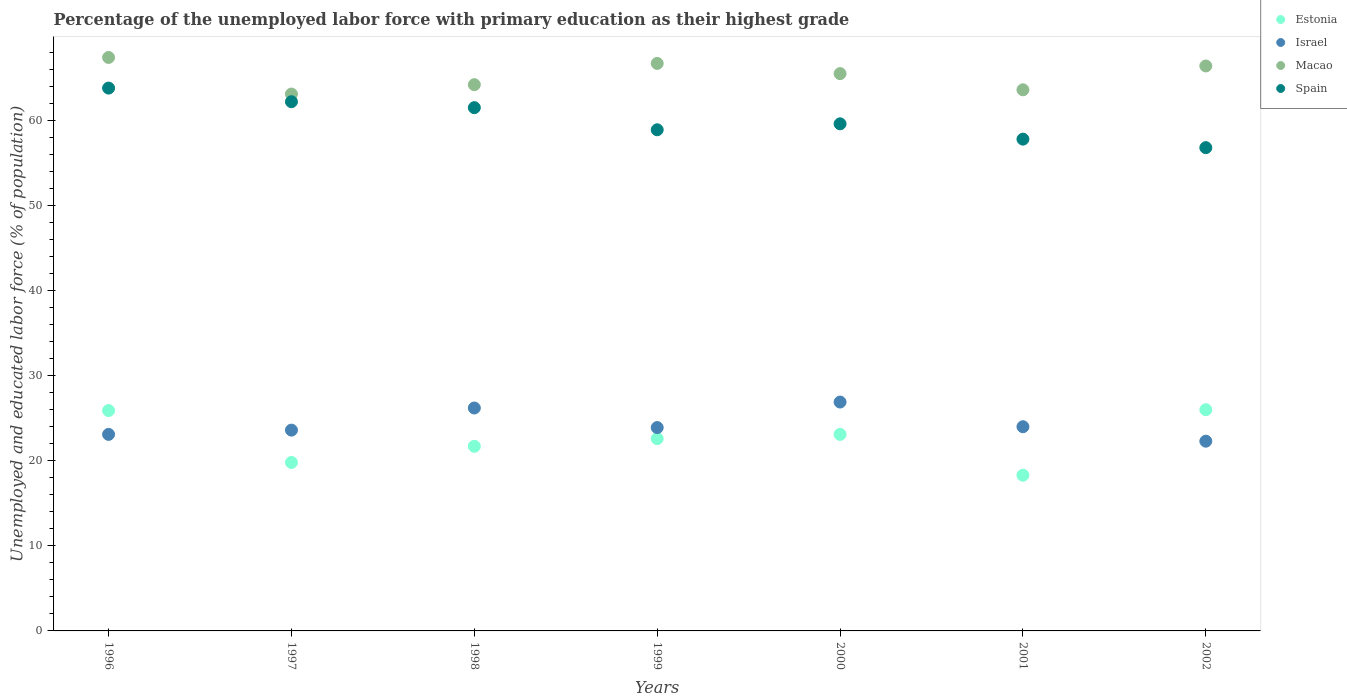Is the number of dotlines equal to the number of legend labels?
Ensure brevity in your answer.  Yes. What is the percentage of the unemployed labor force with primary education in Israel in 2001?
Offer a very short reply. 24. Across all years, what is the maximum percentage of the unemployed labor force with primary education in Spain?
Ensure brevity in your answer.  63.8. Across all years, what is the minimum percentage of the unemployed labor force with primary education in Macao?
Provide a succinct answer. 63.1. In which year was the percentage of the unemployed labor force with primary education in Spain minimum?
Ensure brevity in your answer.  2002. What is the total percentage of the unemployed labor force with primary education in Macao in the graph?
Provide a short and direct response. 456.9. What is the difference between the percentage of the unemployed labor force with primary education in Macao in 1996 and that in 1997?
Offer a very short reply. 4.3. What is the difference between the percentage of the unemployed labor force with primary education in Estonia in 2001 and the percentage of the unemployed labor force with primary education in Macao in 1996?
Your answer should be compact. -49.1. What is the average percentage of the unemployed labor force with primary education in Estonia per year?
Your answer should be compact. 22.49. In the year 1998, what is the difference between the percentage of the unemployed labor force with primary education in Israel and percentage of the unemployed labor force with primary education in Spain?
Offer a very short reply. -35.3. What is the ratio of the percentage of the unemployed labor force with primary education in Macao in 1999 to that in 2000?
Ensure brevity in your answer.  1.02. Is the percentage of the unemployed labor force with primary education in Israel in 1997 less than that in 1998?
Your answer should be compact. Yes. Is the difference between the percentage of the unemployed labor force with primary education in Israel in 1999 and 2002 greater than the difference between the percentage of the unemployed labor force with primary education in Spain in 1999 and 2002?
Keep it short and to the point. No. What is the difference between the highest and the second highest percentage of the unemployed labor force with primary education in Estonia?
Ensure brevity in your answer.  0.1. What is the difference between the highest and the lowest percentage of the unemployed labor force with primary education in Macao?
Ensure brevity in your answer.  4.3. In how many years, is the percentage of the unemployed labor force with primary education in Macao greater than the average percentage of the unemployed labor force with primary education in Macao taken over all years?
Make the answer very short. 4. Is it the case that in every year, the sum of the percentage of the unemployed labor force with primary education in Estonia and percentage of the unemployed labor force with primary education in Macao  is greater than the sum of percentage of the unemployed labor force with primary education in Spain and percentage of the unemployed labor force with primary education in Israel?
Provide a succinct answer. No. Is the percentage of the unemployed labor force with primary education in Spain strictly greater than the percentage of the unemployed labor force with primary education in Israel over the years?
Ensure brevity in your answer.  Yes. What is the difference between two consecutive major ticks on the Y-axis?
Give a very brief answer. 10. Are the values on the major ticks of Y-axis written in scientific E-notation?
Offer a very short reply. No. Where does the legend appear in the graph?
Give a very brief answer. Top right. How are the legend labels stacked?
Your answer should be very brief. Vertical. What is the title of the graph?
Provide a succinct answer. Percentage of the unemployed labor force with primary education as their highest grade. What is the label or title of the X-axis?
Your response must be concise. Years. What is the label or title of the Y-axis?
Give a very brief answer. Unemployed and educated labor force (% of population). What is the Unemployed and educated labor force (% of population) of Estonia in 1996?
Your answer should be very brief. 25.9. What is the Unemployed and educated labor force (% of population) in Israel in 1996?
Give a very brief answer. 23.1. What is the Unemployed and educated labor force (% of population) of Macao in 1996?
Give a very brief answer. 67.4. What is the Unemployed and educated labor force (% of population) in Spain in 1996?
Give a very brief answer. 63.8. What is the Unemployed and educated labor force (% of population) in Estonia in 1997?
Give a very brief answer. 19.8. What is the Unemployed and educated labor force (% of population) of Israel in 1997?
Your answer should be compact. 23.6. What is the Unemployed and educated labor force (% of population) in Macao in 1997?
Ensure brevity in your answer.  63.1. What is the Unemployed and educated labor force (% of population) in Spain in 1997?
Your answer should be very brief. 62.2. What is the Unemployed and educated labor force (% of population) in Estonia in 1998?
Ensure brevity in your answer.  21.7. What is the Unemployed and educated labor force (% of population) of Israel in 1998?
Offer a terse response. 26.2. What is the Unemployed and educated labor force (% of population) in Macao in 1998?
Give a very brief answer. 64.2. What is the Unemployed and educated labor force (% of population) in Spain in 1998?
Offer a very short reply. 61.5. What is the Unemployed and educated labor force (% of population) in Estonia in 1999?
Offer a terse response. 22.6. What is the Unemployed and educated labor force (% of population) in Israel in 1999?
Your response must be concise. 23.9. What is the Unemployed and educated labor force (% of population) of Macao in 1999?
Give a very brief answer. 66.7. What is the Unemployed and educated labor force (% of population) in Spain in 1999?
Offer a very short reply. 58.9. What is the Unemployed and educated labor force (% of population) of Estonia in 2000?
Offer a terse response. 23.1. What is the Unemployed and educated labor force (% of population) of Israel in 2000?
Your response must be concise. 26.9. What is the Unemployed and educated labor force (% of population) in Macao in 2000?
Offer a very short reply. 65.5. What is the Unemployed and educated labor force (% of population) in Spain in 2000?
Offer a terse response. 59.6. What is the Unemployed and educated labor force (% of population) in Estonia in 2001?
Give a very brief answer. 18.3. What is the Unemployed and educated labor force (% of population) of Macao in 2001?
Ensure brevity in your answer.  63.6. What is the Unemployed and educated labor force (% of population) of Spain in 2001?
Offer a very short reply. 57.8. What is the Unemployed and educated labor force (% of population) in Israel in 2002?
Ensure brevity in your answer.  22.3. What is the Unemployed and educated labor force (% of population) of Macao in 2002?
Provide a succinct answer. 66.4. What is the Unemployed and educated labor force (% of population) in Spain in 2002?
Offer a very short reply. 56.8. Across all years, what is the maximum Unemployed and educated labor force (% of population) in Israel?
Your response must be concise. 26.9. Across all years, what is the maximum Unemployed and educated labor force (% of population) in Macao?
Offer a terse response. 67.4. Across all years, what is the maximum Unemployed and educated labor force (% of population) of Spain?
Provide a short and direct response. 63.8. Across all years, what is the minimum Unemployed and educated labor force (% of population) in Estonia?
Your answer should be compact. 18.3. Across all years, what is the minimum Unemployed and educated labor force (% of population) of Israel?
Your response must be concise. 22.3. Across all years, what is the minimum Unemployed and educated labor force (% of population) in Macao?
Make the answer very short. 63.1. Across all years, what is the minimum Unemployed and educated labor force (% of population) of Spain?
Your response must be concise. 56.8. What is the total Unemployed and educated labor force (% of population) in Estonia in the graph?
Ensure brevity in your answer.  157.4. What is the total Unemployed and educated labor force (% of population) in Israel in the graph?
Keep it short and to the point. 170. What is the total Unemployed and educated labor force (% of population) of Macao in the graph?
Your answer should be very brief. 456.9. What is the total Unemployed and educated labor force (% of population) of Spain in the graph?
Your answer should be very brief. 420.6. What is the difference between the Unemployed and educated labor force (% of population) of Estonia in 1996 and that in 1997?
Ensure brevity in your answer.  6.1. What is the difference between the Unemployed and educated labor force (% of population) of Macao in 1996 and that in 1997?
Keep it short and to the point. 4.3. What is the difference between the Unemployed and educated labor force (% of population) in Spain in 1996 and that in 1997?
Provide a short and direct response. 1.6. What is the difference between the Unemployed and educated labor force (% of population) in Israel in 1996 and that in 1998?
Offer a very short reply. -3.1. What is the difference between the Unemployed and educated labor force (% of population) in Macao in 1996 and that in 1998?
Your answer should be very brief. 3.2. What is the difference between the Unemployed and educated labor force (% of population) of Estonia in 1996 and that in 1999?
Your answer should be compact. 3.3. What is the difference between the Unemployed and educated labor force (% of population) in Israel in 1996 and that in 1999?
Make the answer very short. -0.8. What is the difference between the Unemployed and educated labor force (% of population) of Macao in 1996 and that in 1999?
Give a very brief answer. 0.7. What is the difference between the Unemployed and educated labor force (% of population) in Israel in 1996 and that in 2000?
Ensure brevity in your answer.  -3.8. What is the difference between the Unemployed and educated labor force (% of population) in Estonia in 1996 and that in 2001?
Give a very brief answer. 7.6. What is the difference between the Unemployed and educated labor force (% of population) in Macao in 1996 and that in 2001?
Offer a very short reply. 3.8. What is the difference between the Unemployed and educated labor force (% of population) of Israel in 1996 and that in 2002?
Keep it short and to the point. 0.8. What is the difference between the Unemployed and educated labor force (% of population) of Macao in 1996 and that in 2002?
Offer a terse response. 1. What is the difference between the Unemployed and educated labor force (% of population) of Estonia in 1997 and that in 1998?
Provide a succinct answer. -1.9. What is the difference between the Unemployed and educated labor force (% of population) of Israel in 1997 and that in 1998?
Offer a terse response. -2.6. What is the difference between the Unemployed and educated labor force (% of population) of Spain in 1997 and that in 1998?
Provide a short and direct response. 0.7. What is the difference between the Unemployed and educated labor force (% of population) of Estonia in 1997 and that in 1999?
Your response must be concise. -2.8. What is the difference between the Unemployed and educated labor force (% of population) in Israel in 1997 and that in 1999?
Give a very brief answer. -0.3. What is the difference between the Unemployed and educated labor force (% of population) of Estonia in 1997 and that in 2000?
Provide a succinct answer. -3.3. What is the difference between the Unemployed and educated labor force (% of population) of Israel in 1997 and that in 2000?
Ensure brevity in your answer.  -3.3. What is the difference between the Unemployed and educated labor force (% of population) in Macao in 1997 and that in 2000?
Your answer should be compact. -2.4. What is the difference between the Unemployed and educated labor force (% of population) of Spain in 1997 and that in 2000?
Make the answer very short. 2.6. What is the difference between the Unemployed and educated labor force (% of population) of Macao in 1997 and that in 2001?
Keep it short and to the point. -0.5. What is the difference between the Unemployed and educated labor force (% of population) in Estonia in 1997 and that in 2002?
Ensure brevity in your answer.  -6.2. What is the difference between the Unemployed and educated labor force (% of population) of Israel in 1997 and that in 2002?
Provide a succinct answer. 1.3. What is the difference between the Unemployed and educated labor force (% of population) of Macao in 1997 and that in 2002?
Provide a succinct answer. -3.3. What is the difference between the Unemployed and educated labor force (% of population) in Spain in 1997 and that in 2002?
Ensure brevity in your answer.  5.4. What is the difference between the Unemployed and educated labor force (% of population) in Israel in 1998 and that in 1999?
Your answer should be very brief. 2.3. What is the difference between the Unemployed and educated labor force (% of population) in Spain in 1998 and that in 2000?
Offer a terse response. 1.9. What is the difference between the Unemployed and educated labor force (% of population) in Israel in 1998 and that in 2001?
Make the answer very short. 2.2. What is the difference between the Unemployed and educated labor force (% of population) of Spain in 1998 and that in 2001?
Offer a terse response. 3.7. What is the difference between the Unemployed and educated labor force (% of population) of Estonia in 1998 and that in 2002?
Offer a very short reply. -4.3. What is the difference between the Unemployed and educated labor force (% of population) of Macao in 1998 and that in 2002?
Your answer should be very brief. -2.2. What is the difference between the Unemployed and educated labor force (% of population) of Estonia in 1999 and that in 2000?
Keep it short and to the point. -0.5. What is the difference between the Unemployed and educated labor force (% of population) in Macao in 1999 and that in 2000?
Offer a very short reply. 1.2. What is the difference between the Unemployed and educated labor force (% of population) in Spain in 1999 and that in 2000?
Make the answer very short. -0.7. What is the difference between the Unemployed and educated labor force (% of population) of Estonia in 1999 and that in 2001?
Your answer should be compact. 4.3. What is the difference between the Unemployed and educated labor force (% of population) in Macao in 1999 and that in 2001?
Offer a terse response. 3.1. What is the difference between the Unemployed and educated labor force (% of population) in Spain in 1999 and that in 2002?
Ensure brevity in your answer.  2.1. What is the difference between the Unemployed and educated labor force (% of population) of Macao in 2000 and that in 2001?
Offer a very short reply. 1.9. What is the difference between the Unemployed and educated labor force (% of population) of Israel in 2000 and that in 2002?
Provide a succinct answer. 4.6. What is the difference between the Unemployed and educated labor force (% of population) of Macao in 2000 and that in 2002?
Ensure brevity in your answer.  -0.9. What is the difference between the Unemployed and educated labor force (% of population) in Spain in 2000 and that in 2002?
Your answer should be very brief. 2.8. What is the difference between the Unemployed and educated labor force (% of population) of Spain in 2001 and that in 2002?
Your response must be concise. 1. What is the difference between the Unemployed and educated labor force (% of population) in Estonia in 1996 and the Unemployed and educated labor force (% of population) in Israel in 1997?
Offer a very short reply. 2.3. What is the difference between the Unemployed and educated labor force (% of population) of Estonia in 1996 and the Unemployed and educated labor force (% of population) of Macao in 1997?
Keep it short and to the point. -37.2. What is the difference between the Unemployed and educated labor force (% of population) in Estonia in 1996 and the Unemployed and educated labor force (% of population) in Spain in 1997?
Provide a succinct answer. -36.3. What is the difference between the Unemployed and educated labor force (% of population) of Israel in 1996 and the Unemployed and educated labor force (% of population) of Macao in 1997?
Make the answer very short. -40. What is the difference between the Unemployed and educated labor force (% of population) in Israel in 1996 and the Unemployed and educated labor force (% of population) in Spain in 1997?
Your answer should be very brief. -39.1. What is the difference between the Unemployed and educated labor force (% of population) in Estonia in 1996 and the Unemployed and educated labor force (% of population) in Macao in 1998?
Your answer should be compact. -38.3. What is the difference between the Unemployed and educated labor force (% of population) of Estonia in 1996 and the Unemployed and educated labor force (% of population) of Spain in 1998?
Your response must be concise. -35.6. What is the difference between the Unemployed and educated labor force (% of population) of Israel in 1996 and the Unemployed and educated labor force (% of population) of Macao in 1998?
Offer a terse response. -41.1. What is the difference between the Unemployed and educated labor force (% of population) in Israel in 1996 and the Unemployed and educated labor force (% of population) in Spain in 1998?
Offer a terse response. -38.4. What is the difference between the Unemployed and educated labor force (% of population) in Estonia in 1996 and the Unemployed and educated labor force (% of population) in Macao in 1999?
Give a very brief answer. -40.8. What is the difference between the Unemployed and educated labor force (% of population) of Estonia in 1996 and the Unemployed and educated labor force (% of population) of Spain in 1999?
Offer a very short reply. -33. What is the difference between the Unemployed and educated labor force (% of population) of Israel in 1996 and the Unemployed and educated labor force (% of population) of Macao in 1999?
Your answer should be very brief. -43.6. What is the difference between the Unemployed and educated labor force (% of population) of Israel in 1996 and the Unemployed and educated labor force (% of population) of Spain in 1999?
Your response must be concise. -35.8. What is the difference between the Unemployed and educated labor force (% of population) in Macao in 1996 and the Unemployed and educated labor force (% of population) in Spain in 1999?
Your answer should be compact. 8.5. What is the difference between the Unemployed and educated labor force (% of population) in Estonia in 1996 and the Unemployed and educated labor force (% of population) in Israel in 2000?
Your response must be concise. -1. What is the difference between the Unemployed and educated labor force (% of population) of Estonia in 1996 and the Unemployed and educated labor force (% of population) of Macao in 2000?
Keep it short and to the point. -39.6. What is the difference between the Unemployed and educated labor force (% of population) in Estonia in 1996 and the Unemployed and educated labor force (% of population) in Spain in 2000?
Give a very brief answer. -33.7. What is the difference between the Unemployed and educated labor force (% of population) in Israel in 1996 and the Unemployed and educated labor force (% of population) in Macao in 2000?
Your response must be concise. -42.4. What is the difference between the Unemployed and educated labor force (% of population) of Israel in 1996 and the Unemployed and educated labor force (% of population) of Spain in 2000?
Offer a terse response. -36.5. What is the difference between the Unemployed and educated labor force (% of population) in Macao in 1996 and the Unemployed and educated labor force (% of population) in Spain in 2000?
Provide a succinct answer. 7.8. What is the difference between the Unemployed and educated labor force (% of population) in Estonia in 1996 and the Unemployed and educated labor force (% of population) in Macao in 2001?
Your answer should be compact. -37.7. What is the difference between the Unemployed and educated labor force (% of population) of Estonia in 1996 and the Unemployed and educated labor force (% of population) of Spain in 2001?
Offer a very short reply. -31.9. What is the difference between the Unemployed and educated labor force (% of population) of Israel in 1996 and the Unemployed and educated labor force (% of population) of Macao in 2001?
Your answer should be very brief. -40.5. What is the difference between the Unemployed and educated labor force (% of population) of Israel in 1996 and the Unemployed and educated labor force (% of population) of Spain in 2001?
Make the answer very short. -34.7. What is the difference between the Unemployed and educated labor force (% of population) of Macao in 1996 and the Unemployed and educated labor force (% of population) of Spain in 2001?
Provide a succinct answer. 9.6. What is the difference between the Unemployed and educated labor force (% of population) of Estonia in 1996 and the Unemployed and educated labor force (% of population) of Macao in 2002?
Your answer should be compact. -40.5. What is the difference between the Unemployed and educated labor force (% of population) of Estonia in 1996 and the Unemployed and educated labor force (% of population) of Spain in 2002?
Offer a terse response. -30.9. What is the difference between the Unemployed and educated labor force (% of population) of Israel in 1996 and the Unemployed and educated labor force (% of population) of Macao in 2002?
Your answer should be very brief. -43.3. What is the difference between the Unemployed and educated labor force (% of population) of Israel in 1996 and the Unemployed and educated labor force (% of population) of Spain in 2002?
Your answer should be very brief. -33.7. What is the difference between the Unemployed and educated labor force (% of population) of Macao in 1996 and the Unemployed and educated labor force (% of population) of Spain in 2002?
Give a very brief answer. 10.6. What is the difference between the Unemployed and educated labor force (% of population) of Estonia in 1997 and the Unemployed and educated labor force (% of population) of Macao in 1998?
Keep it short and to the point. -44.4. What is the difference between the Unemployed and educated labor force (% of population) in Estonia in 1997 and the Unemployed and educated labor force (% of population) in Spain in 1998?
Ensure brevity in your answer.  -41.7. What is the difference between the Unemployed and educated labor force (% of population) in Israel in 1997 and the Unemployed and educated labor force (% of population) in Macao in 1998?
Ensure brevity in your answer.  -40.6. What is the difference between the Unemployed and educated labor force (% of population) of Israel in 1997 and the Unemployed and educated labor force (% of population) of Spain in 1998?
Keep it short and to the point. -37.9. What is the difference between the Unemployed and educated labor force (% of population) of Estonia in 1997 and the Unemployed and educated labor force (% of population) of Israel in 1999?
Offer a very short reply. -4.1. What is the difference between the Unemployed and educated labor force (% of population) of Estonia in 1997 and the Unemployed and educated labor force (% of population) of Macao in 1999?
Your answer should be very brief. -46.9. What is the difference between the Unemployed and educated labor force (% of population) in Estonia in 1997 and the Unemployed and educated labor force (% of population) in Spain in 1999?
Offer a terse response. -39.1. What is the difference between the Unemployed and educated labor force (% of population) in Israel in 1997 and the Unemployed and educated labor force (% of population) in Macao in 1999?
Give a very brief answer. -43.1. What is the difference between the Unemployed and educated labor force (% of population) in Israel in 1997 and the Unemployed and educated labor force (% of population) in Spain in 1999?
Give a very brief answer. -35.3. What is the difference between the Unemployed and educated labor force (% of population) of Estonia in 1997 and the Unemployed and educated labor force (% of population) of Israel in 2000?
Offer a terse response. -7.1. What is the difference between the Unemployed and educated labor force (% of population) in Estonia in 1997 and the Unemployed and educated labor force (% of population) in Macao in 2000?
Offer a terse response. -45.7. What is the difference between the Unemployed and educated labor force (% of population) of Estonia in 1997 and the Unemployed and educated labor force (% of population) of Spain in 2000?
Give a very brief answer. -39.8. What is the difference between the Unemployed and educated labor force (% of population) in Israel in 1997 and the Unemployed and educated labor force (% of population) in Macao in 2000?
Offer a terse response. -41.9. What is the difference between the Unemployed and educated labor force (% of population) of Israel in 1997 and the Unemployed and educated labor force (% of population) of Spain in 2000?
Provide a short and direct response. -36. What is the difference between the Unemployed and educated labor force (% of population) in Estonia in 1997 and the Unemployed and educated labor force (% of population) in Macao in 2001?
Your answer should be very brief. -43.8. What is the difference between the Unemployed and educated labor force (% of population) of Estonia in 1997 and the Unemployed and educated labor force (% of population) of Spain in 2001?
Ensure brevity in your answer.  -38. What is the difference between the Unemployed and educated labor force (% of population) of Israel in 1997 and the Unemployed and educated labor force (% of population) of Spain in 2001?
Offer a terse response. -34.2. What is the difference between the Unemployed and educated labor force (% of population) in Estonia in 1997 and the Unemployed and educated labor force (% of population) in Macao in 2002?
Your answer should be compact. -46.6. What is the difference between the Unemployed and educated labor force (% of population) of Estonia in 1997 and the Unemployed and educated labor force (% of population) of Spain in 2002?
Your answer should be very brief. -37. What is the difference between the Unemployed and educated labor force (% of population) in Israel in 1997 and the Unemployed and educated labor force (% of population) in Macao in 2002?
Your response must be concise. -42.8. What is the difference between the Unemployed and educated labor force (% of population) in Israel in 1997 and the Unemployed and educated labor force (% of population) in Spain in 2002?
Your response must be concise. -33.2. What is the difference between the Unemployed and educated labor force (% of population) of Estonia in 1998 and the Unemployed and educated labor force (% of population) of Israel in 1999?
Your response must be concise. -2.2. What is the difference between the Unemployed and educated labor force (% of population) of Estonia in 1998 and the Unemployed and educated labor force (% of population) of Macao in 1999?
Your response must be concise. -45. What is the difference between the Unemployed and educated labor force (% of population) in Estonia in 1998 and the Unemployed and educated labor force (% of population) in Spain in 1999?
Keep it short and to the point. -37.2. What is the difference between the Unemployed and educated labor force (% of population) of Israel in 1998 and the Unemployed and educated labor force (% of population) of Macao in 1999?
Make the answer very short. -40.5. What is the difference between the Unemployed and educated labor force (% of population) of Israel in 1998 and the Unemployed and educated labor force (% of population) of Spain in 1999?
Your response must be concise. -32.7. What is the difference between the Unemployed and educated labor force (% of population) in Macao in 1998 and the Unemployed and educated labor force (% of population) in Spain in 1999?
Keep it short and to the point. 5.3. What is the difference between the Unemployed and educated labor force (% of population) in Estonia in 1998 and the Unemployed and educated labor force (% of population) in Israel in 2000?
Make the answer very short. -5.2. What is the difference between the Unemployed and educated labor force (% of population) of Estonia in 1998 and the Unemployed and educated labor force (% of population) of Macao in 2000?
Offer a terse response. -43.8. What is the difference between the Unemployed and educated labor force (% of population) of Estonia in 1998 and the Unemployed and educated labor force (% of population) of Spain in 2000?
Provide a short and direct response. -37.9. What is the difference between the Unemployed and educated labor force (% of population) of Israel in 1998 and the Unemployed and educated labor force (% of population) of Macao in 2000?
Offer a very short reply. -39.3. What is the difference between the Unemployed and educated labor force (% of population) in Israel in 1998 and the Unemployed and educated labor force (% of population) in Spain in 2000?
Your answer should be compact. -33.4. What is the difference between the Unemployed and educated labor force (% of population) in Estonia in 1998 and the Unemployed and educated labor force (% of population) in Israel in 2001?
Your response must be concise. -2.3. What is the difference between the Unemployed and educated labor force (% of population) in Estonia in 1998 and the Unemployed and educated labor force (% of population) in Macao in 2001?
Provide a succinct answer. -41.9. What is the difference between the Unemployed and educated labor force (% of population) in Estonia in 1998 and the Unemployed and educated labor force (% of population) in Spain in 2001?
Your answer should be very brief. -36.1. What is the difference between the Unemployed and educated labor force (% of population) of Israel in 1998 and the Unemployed and educated labor force (% of population) of Macao in 2001?
Offer a very short reply. -37.4. What is the difference between the Unemployed and educated labor force (% of population) in Israel in 1998 and the Unemployed and educated labor force (% of population) in Spain in 2001?
Offer a very short reply. -31.6. What is the difference between the Unemployed and educated labor force (% of population) of Estonia in 1998 and the Unemployed and educated labor force (% of population) of Israel in 2002?
Give a very brief answer. -0.6. What is the difference between the Unemployed and educated labor force (% of population) in Estonia in 1998 and the Unemployed and educated labor force (% of population) in Macao in 2002?
Provide a succinct answer. -44.7. What is the difference between the Unemployed and educated labor force (% of population) of Estonia in 1998 and the Unemployed and educated labor force (% of population) of Spain in 2002?
Offer a terse response. -35.1. What is the difference between the Unemployed and educated labor force (% of population) of Israel in 1998 and the Unemployed and educated labor force (% of population) of Macao in 2002?
Keep it short and to the point. -40.2. What is the difference between the Unemployed and educated labor force (% of population) of Israel in 1998 and the Unemployed and educated labor force (% of population) of Spain in 2002?
Give a very brief answer. -30.6. What is the difference between the Unemployed and educated labor force (% of population) of Estonia in 1999 and the Unemployed and educated labor force (% of population) of Macao in 2000?
Make the answer very short. -42.9. What is the difference between the Unemployed and educated labor force (% of population) of Estonia in 1999 and the Unemployed and educated labor force (% of population) of Spain in 2000?
Your answer should be very brief. -37. What is the difference between the Unemployed and educated labor force (% of population) in Israel in 1999 and the Unemployed and educated labor force (% of population) in Macao in 2000?
Provide a succinct answer. -41.6. What is the difference between the Unemployed and educated labor force (% of population) in Israel in 1999 and the Unemployed and educated labor force (% of population) in Spain in 2000?
Ensure brevity in your answer.  -35.7. What is the difference between the Unemployed and educated labor force (% of population) of Estonia in 1999 and the Unemployed and educated labor force (% of population) of Macao in 2001?
Your response must be concise. -41. What is the difference between the Unemployed and educated labor force (% of population) of Estonia in 1999 and the Unemployed and educated labor force (% of population) of Spain in 2001?
Give a very brief answer. -35.2. What is the difference between the Unemployed and educated labor force (% of population) of Israel in 1999 and the Unemployed and educated labor force (% of population) of Macao in 2001?
Your response must be concise. -39.7. What is the difference between the Unemployed and educated labor force (% of population) of Israel in 1999 and the Unemployed and educated labor force (% of population) of Spain in 2001?
Make the answer very short. -33.9. What is the difference between the Unemployed and educated labor force (% of population) of Estonia in 1999 and the Unemployed and educated labor force (% of population) of Macao in 2002?
Keep it short and to the point. -43.8. What is the difference between the Unemployed and educated labor force (% of population) of Estonia in 1999 and the Unemployed and educated labor force (% of population) of Spain in 2002?
Offer a very short reply. -34.2. What is the difference between the Unemployed and educated labor force (% of population) in Israel in 1999 and the Unemployed and educated labor force (% of population) in Macao in 2002?
Provide a short and direct response. -42.5. What is the difference between the Unemployed and educated labor force (% of population) of Israel in 1999 and the Unemployed and educated labor force (% of population) of Spain in 2002?
Give a very brief answer. -32.9. What is the difference between the Unemployed and educated labor force (% of population) in Macao in 1999 and the Unemployed and educated labor force (% of population) in Spain in 2002?
Offer a terse response. 9.9. What is the difference between the Unemployed and educated labor force (% of population) of Estonia in 2000 and the Unemployed and educated labor force (% of population) of Israel in 2001?
Provide a short and direct response. -0.9. What is the difference between the Unemployed and educated labor force (% of population) of Estonia in 2000 and the Unemployed and educated labor force (% of population) of Macao in 2001?
Your response must be concise. -40.5. What is the difference between the Unemployed and educated labor force (% of population) of Estonia in 2000 and the Unemployed and educated labor force (% of population) of Spain in 2001?
Your answer should be very brief. -34.7. What is the difference between the Unemployed and educated labor force (% of population) in Israel in 2000 and the Unemployed and educated labor force (% of population) in Macao in 2001?
Provide a short and direct response. -36.7. What is the difference between the Unemployed and educated labor force (% of population) of Israel in 2000 and the Unemployed and educated labor force (% of population) of Spain in 2001?
Ensure brevity in your answer.  -30.9. What is the difference between the Unemployed and educated labor force (% of population) in Macao in 2000 and the Unemployed and educated labor force (% of population) in Spain in 2001?
Your answer should be compact. 7.7. What is the difference between the Unemployed and educated labor force (% of population) in Estonia in 2000 and the Unemployed and educated labor force (% of population) in Israel in 2002?
Keep it short and to the point. 0.8. What is the difference between the Unemployed and educated labor force (% of population) of Estonia in 2000 and the Unemployed and educated labor force (% of population) of Macao in 2002?
Your answer should be very brief. -43.3. What is the difference between the Unemployed and educated labor force (% of population) in Estonia in 2000 and the Unemployed and educated labor force (% of population) in Spain in 2002?
Your response must be concise. -33.7. What is the difference between the Unemployed and educated labor force (% of population) in Israel in 2000 and the Unemployed and educated labor force (% of population) in Macao in 2002?
Provide a succinct answer. -39.5. What is the difference between the Unemployed and educated labor force (% of population) of Israel in 2000 and the Unemployed and educated labor force (% of population) of Spain in 2002?
Your response must be concise. -29.9. What is the difference between the Unemployed and educated labor force (% of population) of Estonia in 2001 and the Unemployed and educated labor force (% of population) of Macao in 2002?
Give a very brief answer. -48.1. What is the difference between the Unemployed and educated labor force (% of population) in Estonia in 2001 and the Unemployed and educated labor force (% of population) in Spain in 2002?
Give a very brief answer. -38.5. What is the difference between the Unemployed and educated labor force (% of population) of Israel in 2001 and the Unemployed and educated labor force (% of population) of Macao in 2002?
Give a very brief answer. -42.4. What is the difference between the Unemployed and educated labor force (% of population) of Israel in 2001 and the Unemployed and educated labor force (% of population) of Spain in 2002?
Your answer should be compact. -32.8. What is the difference between the Unemployed and educated labor force (% of population) of Macao in 2001 and the Unemployed and educated labor force (% of population) of Spain in 2002?
Offer a terse response. 6.8. What is the average Unemployed and educated labor force (% of population) in Estonia per year?
Your answer should be very brief. 22.49. What is the average Unemployed and educated labor force (% of population) of Israel per year?
Give a very brief answer. 24.29. What is the average Unemployed and educated labor force (% of population) in Macao per year?
Provide a short and direct response. 65.27. What is the average Unemployed and educated labor force (% of population) of Spain per year?
Keep it short and to the point. 60.09. In the year 1996, what is the difference between the Unemployed and educated labor force (% of population) in Estonia and Unemployed and educated labor force (% of population) in Macao?
Provide a short and direct response. -41.5. In the year 1996, what is the difference between the Unemployed and educated labor force (% of population) of Estonia and Unemployed and educated labor force (% of population) of Spain?
Make the answer very short. -37.9. In the year 1996, what is the difference between the Unemployed and educated labor force (% of population) of Israel and Unemployed and educated labor force (% of population) of Macao?
Your answer should be very brief. -44.3. In the year 1996, what is the difference between the Unemployed and educated labor force (% of population) of Israel and Unemployed and educated labor force (% of population) of Spain?
Offer a very short reply. -40.7. In the year 1997, what is the difference between the Unemployed and educated labor force (% of population) in Estonia and Unemployed and educated labor force (% of population) in Macao?
Provide a succinct answer. -43.3. In the year 1997, what is the difference between the Unemployed and educated labor force (% of population) in Estonia and Unemployed and educated labor force (% of population) in Spain?
Provide a short and direct response. -42.4. In the year 1997, what is the difference between the Unemployed and educated labor force (% of population) of Israel and Unemployed and educated labor force (% of population) of Macao?
Give a very brief answer. -39.5. In the year 1997, what is the difference between the Unemployed and educated labor force (% of population) of Israel and Unemployed and educated labor force (% of population) of Spain?
Provide a succinct answer. -38.6. In the year 1997, what is the difference between the Unemployed and educated labor force (% of population) of Macao and Unemployed and educated labor force (% of population) of Spain?
Your response must be concise. 0.9. In the year 1998, what is the difference between the Unemployed and educated labor force (% of population) in Estonia and Unemployed and educated labor force (% of population) in Israel?
Your answer should be compact. -4.5. In the year 1998, what is the difference between the Unemployed and educated labor force (% of population) in Estonia and Unemployed and educated labor force (% of population) in Macao?
Provide a short and direct response. -42.5. In the year 1998, what is the difference between the Unemployed and educated labor force (% of population) of Estonia and Unemployed and educated labor force (% of population) of Spain?
Ensure brevity in your answer.  -39.8. In the year 1998, what is the difference between the Unemployed and educated labor force (% of population) in Israel and Unemployed and educated labor force (% of population) in Macao?
Your answer should be compact. -38. In the year 1998, what is the difference between the Unemployed and educated labor force (% of population) of Israel and Unemployed and educated labor force (% of population) of Spain?
Your response must be concise. -35.3. In the year 1999, what is the difference between the Unemployed and educated labor force (% of population) in Estonia and Unemployed and educated labor force (% of population) in Macao?
Provide a succinct answer. -44.1. In the year 1999, what is the difference between the Unemployed and educated labor force (% of population) in Estonia and Unemployed and educated labor force (% of population) in Spain?
Provide a succinct answer. -36.3. In the year 1999, what is the difference between the Unemployed and educated labor force (% of population) of Israel and Unemployed and educated labor force (% of population) of Macao?
Offer a very short reply. -42.8. In the year 1999, what is the difference between the Unemployed and educated labor force (% of population) of Israel and Unemployed and educated labor force (% of population) of Spain?
Your answer should be very brief. -35. In the year 2000, what is the difference between the Unemployed and educated labor force (% of population) in Estonia and Unemployed and educated labor force (% of population) in Israel?
Your answer should be compact. -3.8. In the year 2000, what is the difference between the Unemployed and educated labor force (% of population) in Estonia and Unemployed and educated labor force (% of population) in Macao?
Your answer should be very brief. -42.4. In the year 2000, what is the difference between the Unemployed and educated labor force (% of population) in Estonia and Unemployed and educated labor force (% of population) in Spain?
Offer a terse response. -36.5. In the year 2000, what is the difference between the Unemployed and educated labor force (% of population) of Israel and Unemployed and educated labor force (% of population) of Macao?
Keep it short and to the point. -38.6. In the year 2000, what is the difference between the Unemployed and educated labor force (% of population) of Israel and Unemployed and educated labor force (% of population) of Spain?
Your answer should be very brief. -32.7. In the year 2000, what is the difference between the Unemployed and educated labor force (% of population) in Macao and Unemployed and educated labor force (% of population) in Spain?
Your answer should be compact. 5.9. In the year 2001, what is the difference between the Unemployed and educated labor force (% of population) of Estonia and Unemployed and educated labor force (% of population) of Israel?
Make the answer very short. -5.7. In the year 2001, what is the difference between the Unemployed and educated labor force (% of population) in Estonia and Unemployed and educated labor force (% of population) in Macao?
Provide a succinct answer. -45.3. In the year 2001, what is the difference between the Unemployed and educated labor force (% of population) in Estonia and Unemployed and educated labor force (% of population) in Spain?
Provide a short and direct response. -39.5. In the year 2001, what is the difference between the Unemployed and educated labor force (% of population) of Israel and Unemployed and educated labor force (% of population) of Macao?
Your answer should be compact. -39.6. In the year 2001, what is the difference between the Unemployed and educated labor force (% of population) of Israel and Unemployed and educated labor force (% of population) of Spain?
Give a very brief answer. -33.8. In the year 2001, what is the difference between the Unemployed and educated labor force (% of population) in Macao and Unemployed and educated labor force (% of population) in Spain?
Offer a terse response. 5.8. In the year 2002, what is the difference between the Unemployed and educated labor force (% of population) in Estonia and Unemployed and educated labor force (% of population) in Macao?
Your answer should be very brief. -40.4. In the year 2002, what is the difference between the Unemployed and educated labor force (% of population) of Estonia and Unemployed and educated labor force (% of population) of Spain?
Your answer should be very brief. -30.8. In the year 2002, what is the difference between the Unemployed and educated labor force (% of population) of Israel and Unemployed and educated labor force (% of population) of Macao?
Your response must be concise. -44.1. In the year 2002, what is the difference between the Unemployed and educated labor force (% of population) of Israel and Unemployed and educated labor force (% of population) of Spain?
Provide a short and direct response. -34.5. In the year 2002, what is the difference between the Unemployed and educated labor force (% of population) in Macao and Unemployed and educated labor force (% of population) in Spain?
Provide a short and direct response. 9.6. What is the ratio of the Unemployed and educated labor force (% of population) in Estonia in 1996 to that in 1997?
Your response must be concise. 1.31. What is the ratio of the Unemployed and educated labor force (% of population) of Israel in 1996 to that in 1997?
Offer a very short reply. 0.98. What is the ratio of the Unemployed and educated labor force (% of population) in Macao in 1996 to that in 1997?
Your answer should be compact. 1.07. What is the ratio of the Unemployed and educated labor force (% of population) in Spain in 1996 to that in 1997?
Make the answer very short. 1.03. What is the ratio of the Unemployed and educated labor force (% of population) of Estonia in 1996 to that in 1998?
Offer a very short reply. 1.19. What is the ratio of the Unemployed and educated labor force (% of population) in Israel in 1996 to that in 1998?
Your answer should be very brief. 0.88. What is the ratio of the Unemployed and educated labor force (% of population) of Macao in 1996 to that in 1998?
Provide a short and direct response. 1.05. What is the ratio of the Unemployed and educated labor force (% of population) of Spain in 1996 to that in 1998?
Ensure brevity in your answer.  1.04. What is the ratio of the Unemployed and educated labor force (% of population) in Estonia in 1996 to that in 1999?
Offer a very short reply. 1.15. What is the ratio of the Unemployed and educated labor force (% of population) in Israel in 1996 to that in 1999?
Your answer should be compact. 0.97. What is the ratio of the Unemployed and educated labor force (% of population) of Macao in 1996 to that in 1999?
Offer a terse response. 1.01. What is the ratio of the Unemployed and educated labor force (% of population) of Spain in 1996 to that in 1999?
Make the answer very short. 1.08. What is the ratio of the Unemployed and educated labor force (% of population) of Estonia in 1996 to that in 2000?
Offer a very short reply. 1.12. What is the ratio of the Unemployed and educated labor force (% of population) of Israel in 1996 to that in 2000?
Your response must be concise. 0.86. What is the ratio of the Unemployed and educated labor force (% of population) in Spain in 1996 to that in 2000?
Provide a short and direct response. 1.07. What is the ratio of the Unemployed and educated labor force (% of population) of Estonia in 1996 to that in 2001?
Give a very brief answer. 1.42. What is the ratio of the Unemployed and educated labor force (% of population) in Israel in 1996 to that in 2001?
Your answer should be compact. 0.96. What is the ratio of the Unemployed and educated labor force (% of population) of Macao in 1996 to that in 2001?
Your answer should be very brief. 1.06. What is the ratio of the Unemployed and educated labor force (% of population) of Spain in 1996 to that in 2001?
Make the answer very short. 1.1. What is the ratio of the Unemployed and educated labor force (% of population) of Estonia in 1996 to that in 2002?
Ensure brevity in your answer.  1. What is the ratio of the Unemployed and educated labor force (% of population) in Israel in 1996 to that in 2002?
Provide a short and direct response. 1.04. What is the ratio of the Unemployed and educated labor force (% of population) in Macao in 1996 to that in 2002?
Offer a terse response. 1.02. What is the ratio of the Unemployed and educated labor force (% of population) of Spain in 1996 to that in 2002?
Give a very brief answer. 1.12. What is the ratio of the Unemployed and educated labor force (% of population) in Estonia in 1997 to that in 1998?
Your answer should be very brief. 0.91. What is the ratio of the Unemployed and educated labor force (% of population) in Israel in 1997 to that in 1998?
Keep it short and to the point. 0.9. What is the ratio of the Unemployed and educated labor force (% of population) in Macao in 1997 to that in 1998?
Provide a succinct answer. 0.98. What is the ratio of the Unemployed and educated labor force (% of population) of Spain in 1997 to that in 1998?
Keep it short and to the point. 1.01. What is the ratio of the Unemployed and educated labor force (% of population) in Estonia in 1997 to that in 1999?
Ensure brevity in your answer.  0.88. What is the ratio of the Unemployed and educated labor force (% of population) of Israel in 1997 to that in 1999?
Give a very brief answer. 0.99. What is the ratio of the Unemployed and educated labor force (% of population) in Macao in 1997 to that in 1999?
Your answer should be very brief. 0.95. What is the ratio of the Unemployed and educated labor force (% of population) of Spain in 1997 to that in 1999?
Ensure brevity in your answer.  1.06. What is the ratio of the Unemployed and educated labor force (% of population) in Israel in 1997 to that in 2000?
Keep it short and to the point. 0.88. What is the ratio of the Unemployed and educated labor force (% of population) in Macao in 1997 to that in 2000?
Give a very brief answer. 0.96. What is the ratio of the Unemployed and educated labor force (% of population) of Spain in 1997 to that in 2000?
Ensure brevity in your answer.  1.04. What is the ratio of the Unemployed and educated labor force (% of population) in Estonia in 1997 to that in 2001?
Keep it short and to the point. 1.08. What is the ratio of the Unemployed and educated labor force (% of population) of Israel in 1997 to that in 2001?
Keep it short and to the point. 0.98. What is the ratio of the Unemployed and educated labor force (% of population) of Macao in 1997 to that in 2001?
Your response must be concise. 0.99. What is the ratio of the Unemployed and educated labor force (% of population) of Spain in 1997 to that in 2001?
Offer a very short reply. 1.08. What is the ratio of the Unemployed and educated labor force (% of population) in Estonia in 1997 to that in 2002?
Provide a short and direct response. 0.76. What is the ratio of the Unemployed and educated labor force (% of population) in Israel in 1997 to that in 2002?
Ensure brevity in your answer.  1.06. What is the ratio of the Unemployed and educated labor force (% of population) in Macao in 1997 to that in 2002?
Offer a terse response. 0.95. What is the ratio of the Unemployed and educated labor force (% of population) of Spain in 1997 to that in 2002?
Offer a terse response. 1.1. What is the ratio of the Unemployed and educated labor force (% of population) in Estonia in 1998 to that in 1999?
Your response must be concise. 0.96. What is the ratio of the Unemployed and educated labor force (% of population) in Israel in 1998 to that in 1999?
Provide a short and direct response. 1.1. What is the ratio of the Unemployed and educated labor force (% of population) of Macao in 1998 to that in 1999?
Give a very brief answer. 0.96. What is the ratio of the Unemployed and educated labor force (% of population) in Spain in 1998 to that in 1999?
Your answer should be very brief. 1.04. What is the ratio of the Unemployed and educated labor force (% of population) of Estonia in 1998 to that in 2000?
Your answer should be very brief. 0.94. What is the ratio of the Unemployed and educated labor force (% of population) of Israel in 1998 to that in 2000?
Ensure brevity in your answer.  0.97. What is the ratio of the Unemployed and educated labor force (% of population) of Macao in 1998 to that in 2000?
Provide a succinct answer. 0.98. What is the ratio of the Unemployed and educated labor force (% of population) of Spain in 1998 to that in 2000?
Your answer should be very brief. 1.03. What is the ratio of the Unemployed and educated labor force (% of population) in Estonia in 1998 to that in 2001?
Your answer should be very brief. 1.19. What is the ratio of the Unemployed and educated labor force (% of population) in Israel in 1998 to that in 2001?
Keep it short and to the point. 1.09. What is the ratio of the Unemployed and educated labor force (% of population) in Macao in 1998 to that in 2001?
Your response must be concise. 1.01. What is the ratio of the Unemployed and educated labor force (% of population) in Spain in 1998 to that in 2001?
Ensure brevity in your answer.  1.06. What is the ratio of the Unemployed and educated labor force (% of population) in Estonia in 1998 to that in 2002?
Ensure brevity in your answer.  0.83. What is the ratio of the Unemployed and educated labor force (% of population) of Israel in 1998 to that in 2002?
Offer a terse response. 1.17. What is the ratio of the Unemployed and educated labor force (% of population) in Macao in 1998 to that in 2002?
Keep it short and to the point. 0.97. What is the ratio of the Unemployed and educated labor force (% of population) in Spain in 1998 to that in 2002?
Provide a succinct answer. 1.08. What is the ratio of the Unemployed and educated labor force (% of population) of Estonia in 1999 to that in 2000?
Make the answer very short. 0.98. What is the ratio of the Unemployed and educated labor force (% of population) in Israel in 1999 to that in 2000?
Ensure brevity in your answer.  0.89. What is the ratio of the Unemployed and educated labor force (% of population) of Macao in 1999 to that in 2000?
Provide a short and direct response. 1.02. What is the ratio of the Unemployed and educated labor force (% of population) in Spain in 1999 to that in 2000?
Make the answer very short. 0.99. What is the ratio of the Unemployed and educated labor force (% of population) of Estonia in 1999 to that in 2001?
Give a very brief answer. 1.24. What is the ratio of the Unemployed and educated labor force (% of population) of Macao in 1999 to that in 2001?
Provide a succinct answer. 1.05. What is the ratio of the Unemployed and educated labor force (% of population) of Spain in 1999 to that in 2001?
Offer a terse response. 1.02. What is the ratio of the Unemployed and educated labor force (% of population) in Estonia in 1999 to that in 2002?
Make the answer very short. 0.87. What is the ratio of the Unemployed and educated labor force (% of population) in Israel in 1999 to that in 2002?
Your response must be concise. 1.07. What is the ratio of the Unemployed and educated labor force (% of population) in Macao in 1999 to that in 2002?
Offer a terse response. 1. What is the ratio of the Unemployed and educated labor force (% of population) of Spain in 1999 to that in 2002?
Provide a short and direct response. 1.04. What is the ratio of the Unemployed and educated labor force (% of population) in Estonia in 2000 to that in 2001?
Provide a short and direct response. 1.26. What is the ratio of the Unemployed and educated labor force (% of population) in Israel in 2000 to that in 2001?
Your answer should be compact. 1.12. What is the ratio of the Unemployed and educated labor force (% of population) of Macao in 2000 to that in 2001?
Ensure brevity in your answer.  1.03. What is the ratio of the Unemployed and educated labor force (% of population) in Spain in 2000 to that in 2001?
Ensure brevity in your answer.  1.03. What is the ratio of the Unemployed and educated labor force (% of population) of Estonia in 2000 to that in 2002?
Offer a terse response. 0.89. What is the ratio of the Unemployed and educated labor force (% of population) in Israel in 2000 to that in 2002?
Make the answer very short. 1.21. What is the ratio of the Unemployed and educated labor force (% of population) in Macao in 2000 to that in 2002?
Offer a terse response. 0.99. What is the ratio of the Unemployed and educated labor force (% of population) in Spain in 2000 to that in 2002?
Give a very brief answer. 1.05. What is the ratio of the Unemployed and educated labor force (% of population) of Estonia in 2001 to that in 2002?
Your answer should be very brief. 0.7. What is the ratio of the Unemployed and educated labor force (% of population) in Israel in 2001 to that in 2002?
Your answer should be compact. 1.08. What is the ratio of the Unemployed and educated labor force (% of population) in Macao in 2001 to that in 2002?
Provide a short and direct response. 0.96. What is the ratio of the Unemployed and educated labor force (% of population) in Spain in 2001 to that in 2002?
Give a very brief answer. 1.02. What is the difference between the highest and the second highest Unemployed and educated labor force (% of population) in Israel?
Your response must be concise. 0.7. What is the difference between the highest and the second highest Unemployed and educated labor force (% of population) in Spain?
Your answer should be very brief. 1.6. What is the difference between the highest and the lowest Unemployed and educated labor force (% of population) in Estonia?
Provide a succinct answer. 7.7. What is the difference between the highest and the lowest Unemployed and educated labor force (% of population) of Macao?
Give a very brief answer. 4.3. 